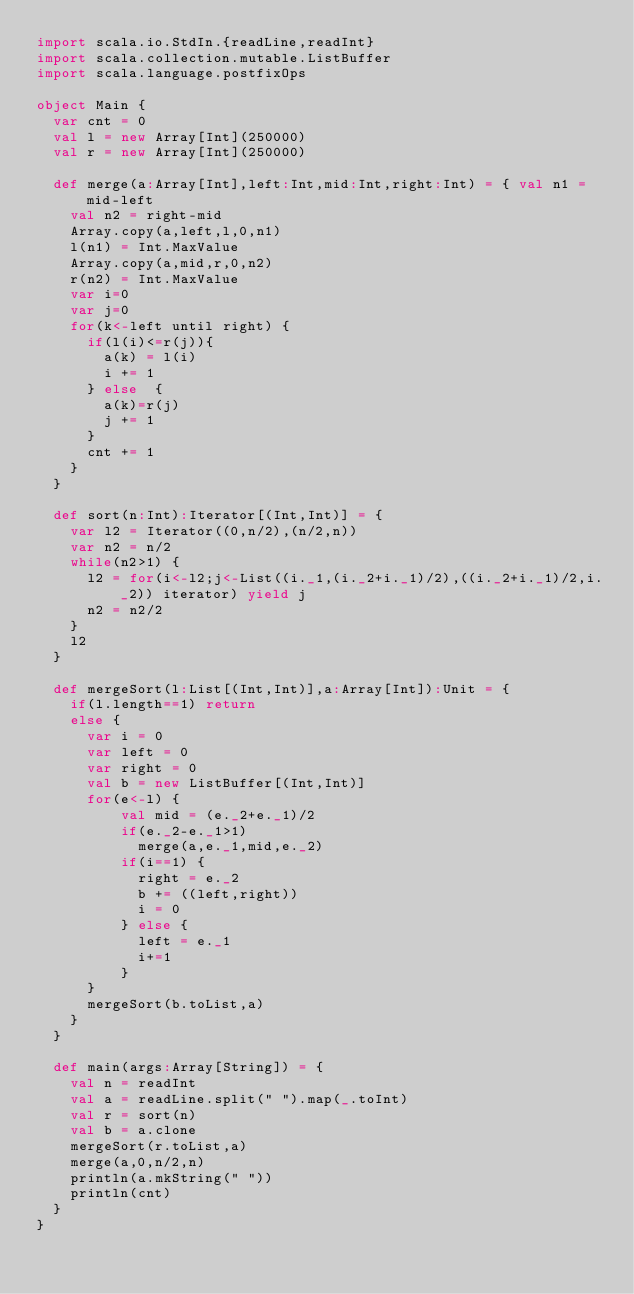Convert code to text. <code><loc_0><loc_0><loc_500><loc_500><_Scala_>import scala.io.StdIn.{readLine,readInt}
import scala.collection.mutable.ListBuffer
import scala.language.postfixOps

object Main {
  var cnt = 0
  val l = new Array[Int](250000)
  val r = new Array[Int](250000)

  def merge(a:Array[Int],left:Int,mid:Int,right:Int) = { val n1 = mid-left
    val n2 = right-mid
    Array.copy(a,left,l,0,n1)
    l(n1) = Int.MaxValue
    Array.copy(a,mid,r,0,n2)
    r(n2) = Int.MaxValue
    var i=0
    var j=0
    for(k<-left until right) {
      if(l(i)<=r(j)){
        a(k) = l(i)
        i += 1
      } else  {
        a(k)=r(j)
        j += 1
      }
      cnt += 1
    }
  }

  def sort(n:Int):Iterator[(Int,Int)] = {
    var l2 = Iterator((0,n/2),(n/2,n))
    var n2 = n/2
    while(n2>1) {
      l2 = for(i<-l2;j<-List((i._1,(i._2+i._1)/2),((i._2+i._1)/2,i._2)) iterator) yield j
      n2 = n2/2
    }
    l2
  }

  def mergeSort(l:List[(Int,Int)],a:Array[Int]):Unit = {
    if(l.length==1) return
    else {
      var i = 0
      var left = 0
      var right = 0
      val b = new ListBuffer[(Int,Int)]
      for(e<-l) {
          val mid = (e._2+e._1)/2
          if(e._2-e._1>1)
            merge(a,e._1,mid,e._2)
          if(i==1) {
            right = e._2
            b += ((left,right))
            i = 0
          } else {
            left = e._1
            i+=1
          }
      }
      mergeSort(b.toList,a)
    }
  }

  def main(args:Array[String]) = {
    val n = readInt
    val a = readLine.split(" ").map(_.toInt)
    val r = sort(n)
    val b = a.clone
    mergeSort(r.toList,a)
    merge(a,0,n/2,n)
    println(a.mkString(" "))
    println(cnt)
  }
}</code> 